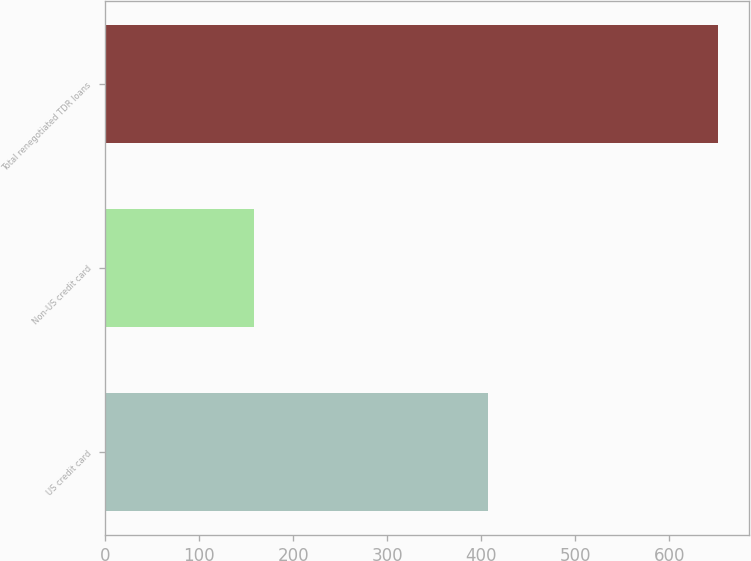Convert chart to OTSL. <chart><loc_0><loc_0><loc_500><loc_500><bar_chart><fcel>US credit card<fcel>Non-US credit card<fcel>Total renegotiated TDR loans<nl><fcel>407<fcel>158<fcel>652<nl></chart> 